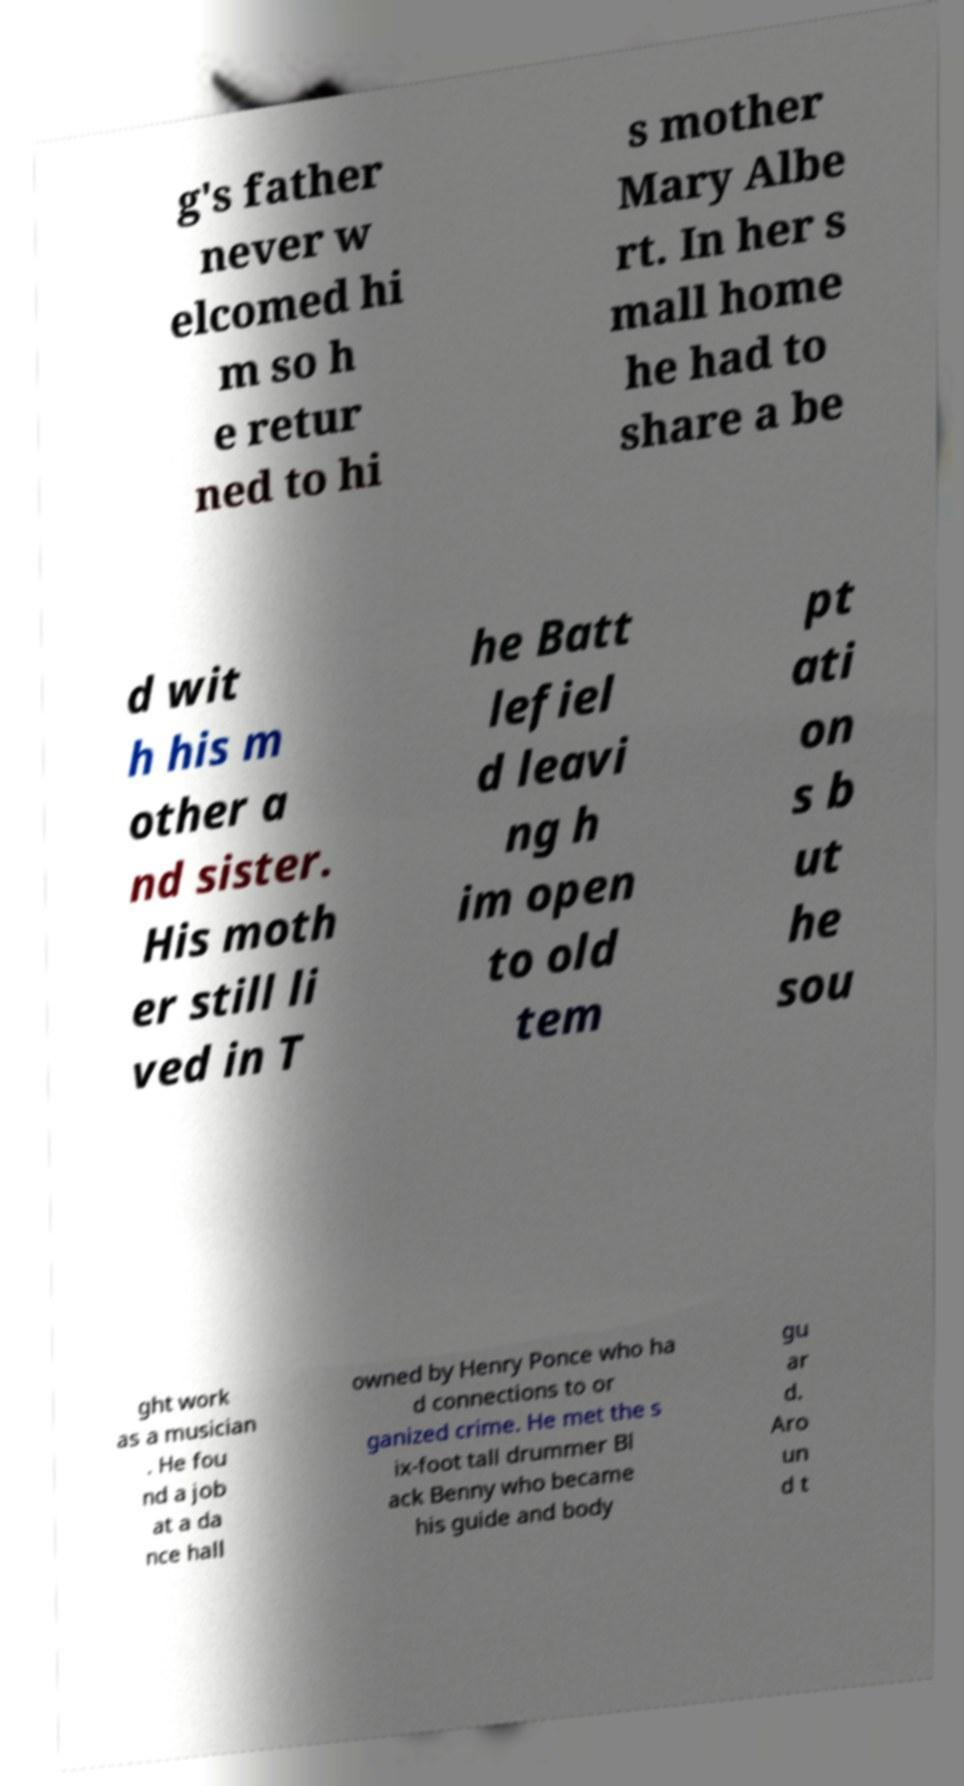Could you assist in decoding the text presented in this image and type it out clearly? g's father never w elcomed hi m so h e retur ned to hi s mother Mary Albe rt. In her s mall home he had to share a be d wit h his m other a nd sister. His moth er still li ved in T he Batt lefiel d leavi ng h im open to old tem pt ati on s b ut he sou ght work as a musician . He fou nd a job at a da nce hall owned by Henry Ponce who ha d connections to or ganized crime. He met the s ix-foot tall drummer Bl ack Benny who became his guide and body gu ar d. Aro un d t 